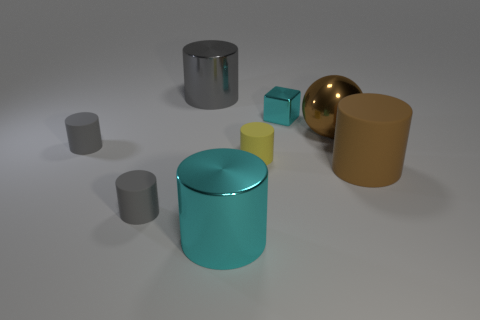The large thing that is the same color as the shiny ball is what shape?
Ensure brevity in your answer.  Cylinder. How many big cylinders have the same color as the sphere?
Offer a very short reply. 1. Are there fewer small matte cylinders that are left of the yellow rubber thing than small yellow things?
Provide a short and direct response. No. What color is the small cylinder to the right of the large gray shiny thing behind the big cyan cylinder?
Offer a terse response. Yellow. There is a cyan metallic thing that is right of the large shiny cylinder in front of the cylinder that is behind the metallic block; how big is it?
Ensure brevity in your answer.  Small. Are there fewer big gray metal cylinders behind the large gray thing than objects that are to the right of the brown metallic object?
Ensure brevity in your answer.  Yes. How many cyan blocks have the same material as the big gray cylinder?
Your response must be concise. 1. There is a matte object that is right of the small matte cylinder that is right of the large gray object; are there any rubber things that are behind it?
Your answer should be compact. Yes. What is the shape of the tiny object that is the same material as the big gray cylinder?
Provide a succinct answer. Cube. Is the number of gray rubber cylinders greater than the number of big cylinders?
Your response must be concise. No. 